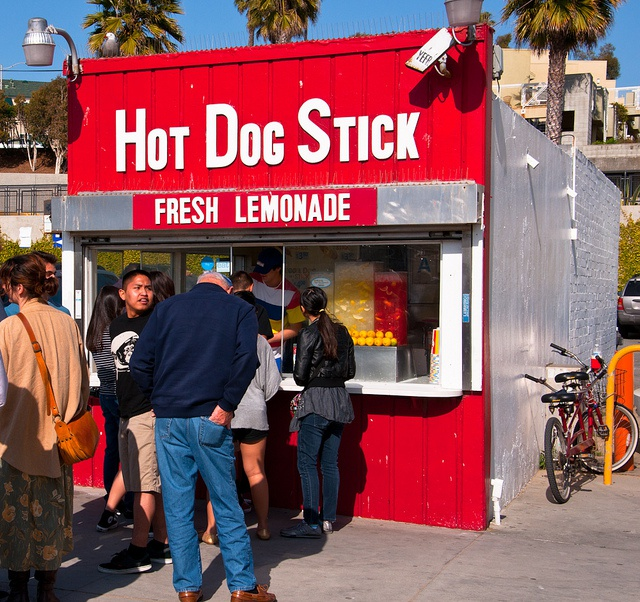Describe the objects in this image and their specific colors. I can see people in lightblue, black, blue, and navy tones, people in lightblue, black, maroon, and tan tones, people in lightblue, black, gray, and maroon tones, people in lightblue, black, tan, maroon, and lightgray tones, and people in lightblue, black, darkgray, maroon, and salmon tones in this image. 